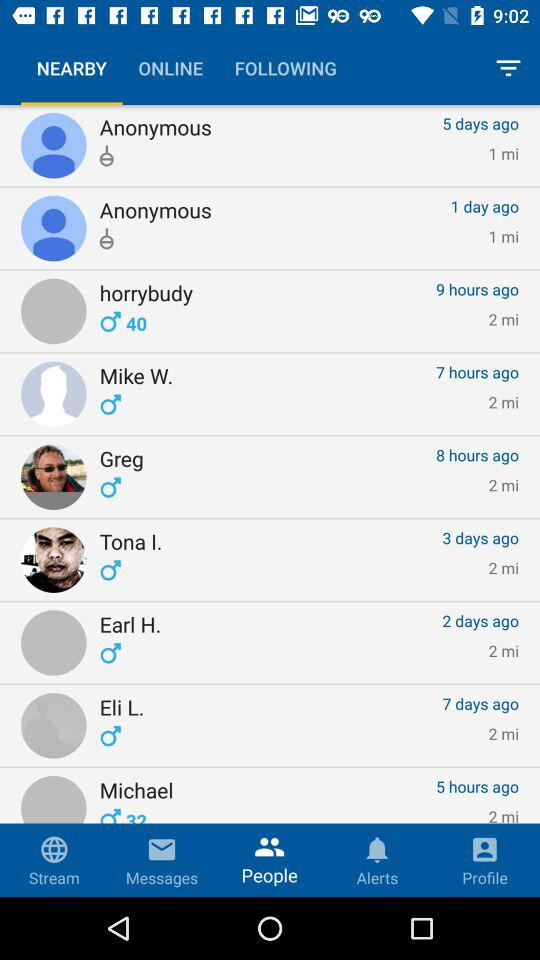What is the age of "horrybudy"? The age of "horrybudy" is 40 years. 